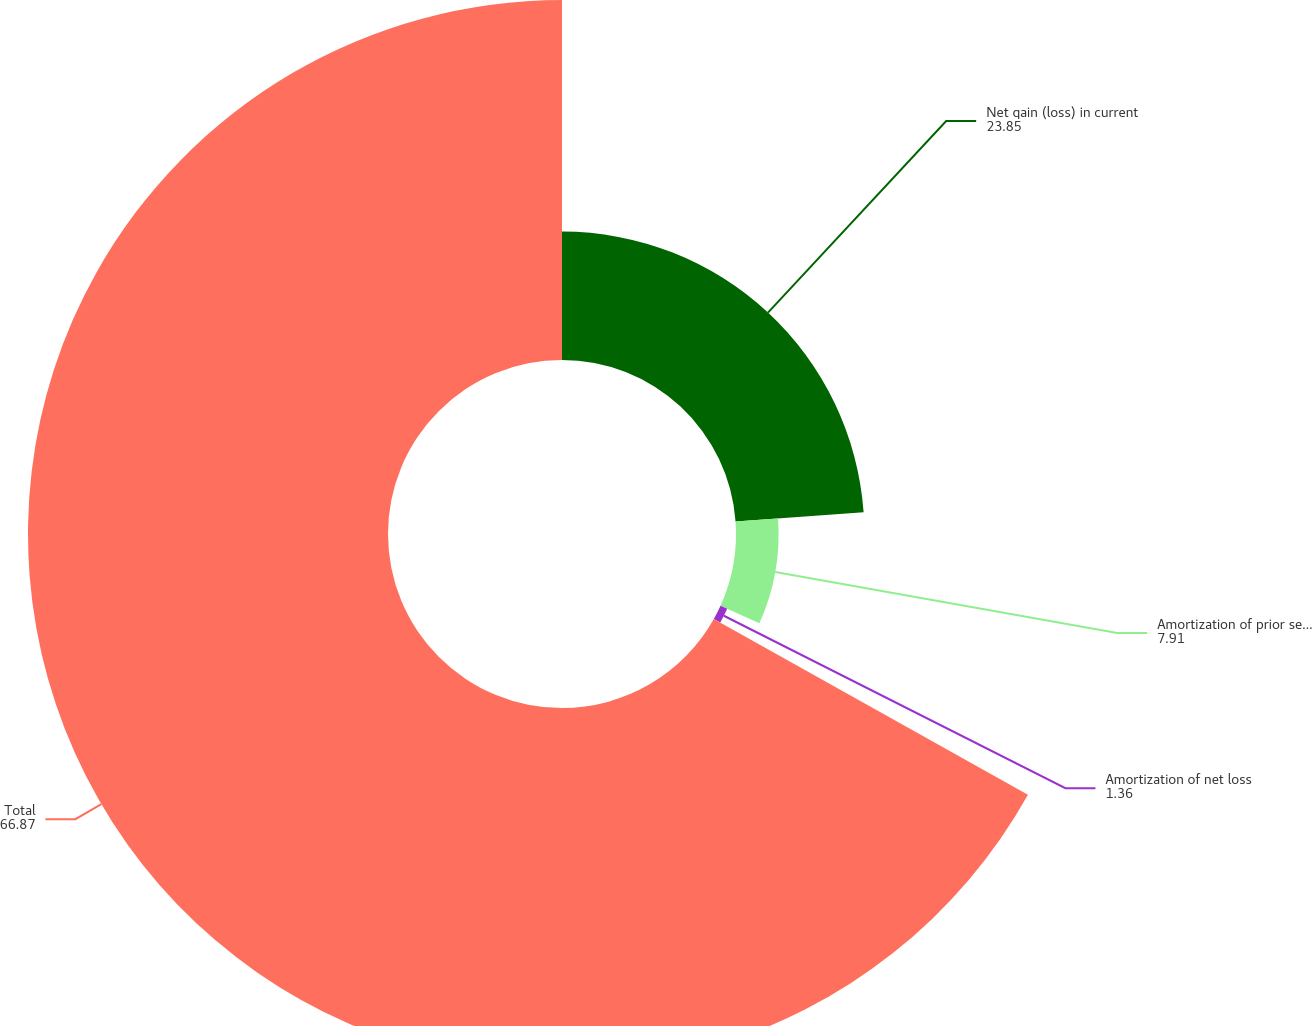<chart> <loc_0><loc_0><loc_500><loc_500><pie_chart><fcel>Net gain (loss) in current<fcel>Amortization of prior service<fcel>Amortization of net loss<fcel>Total<nl><fcel>23.85%<fcel>7.91%<fcel>1.36%<fcel>66.87%<nl></chart> 